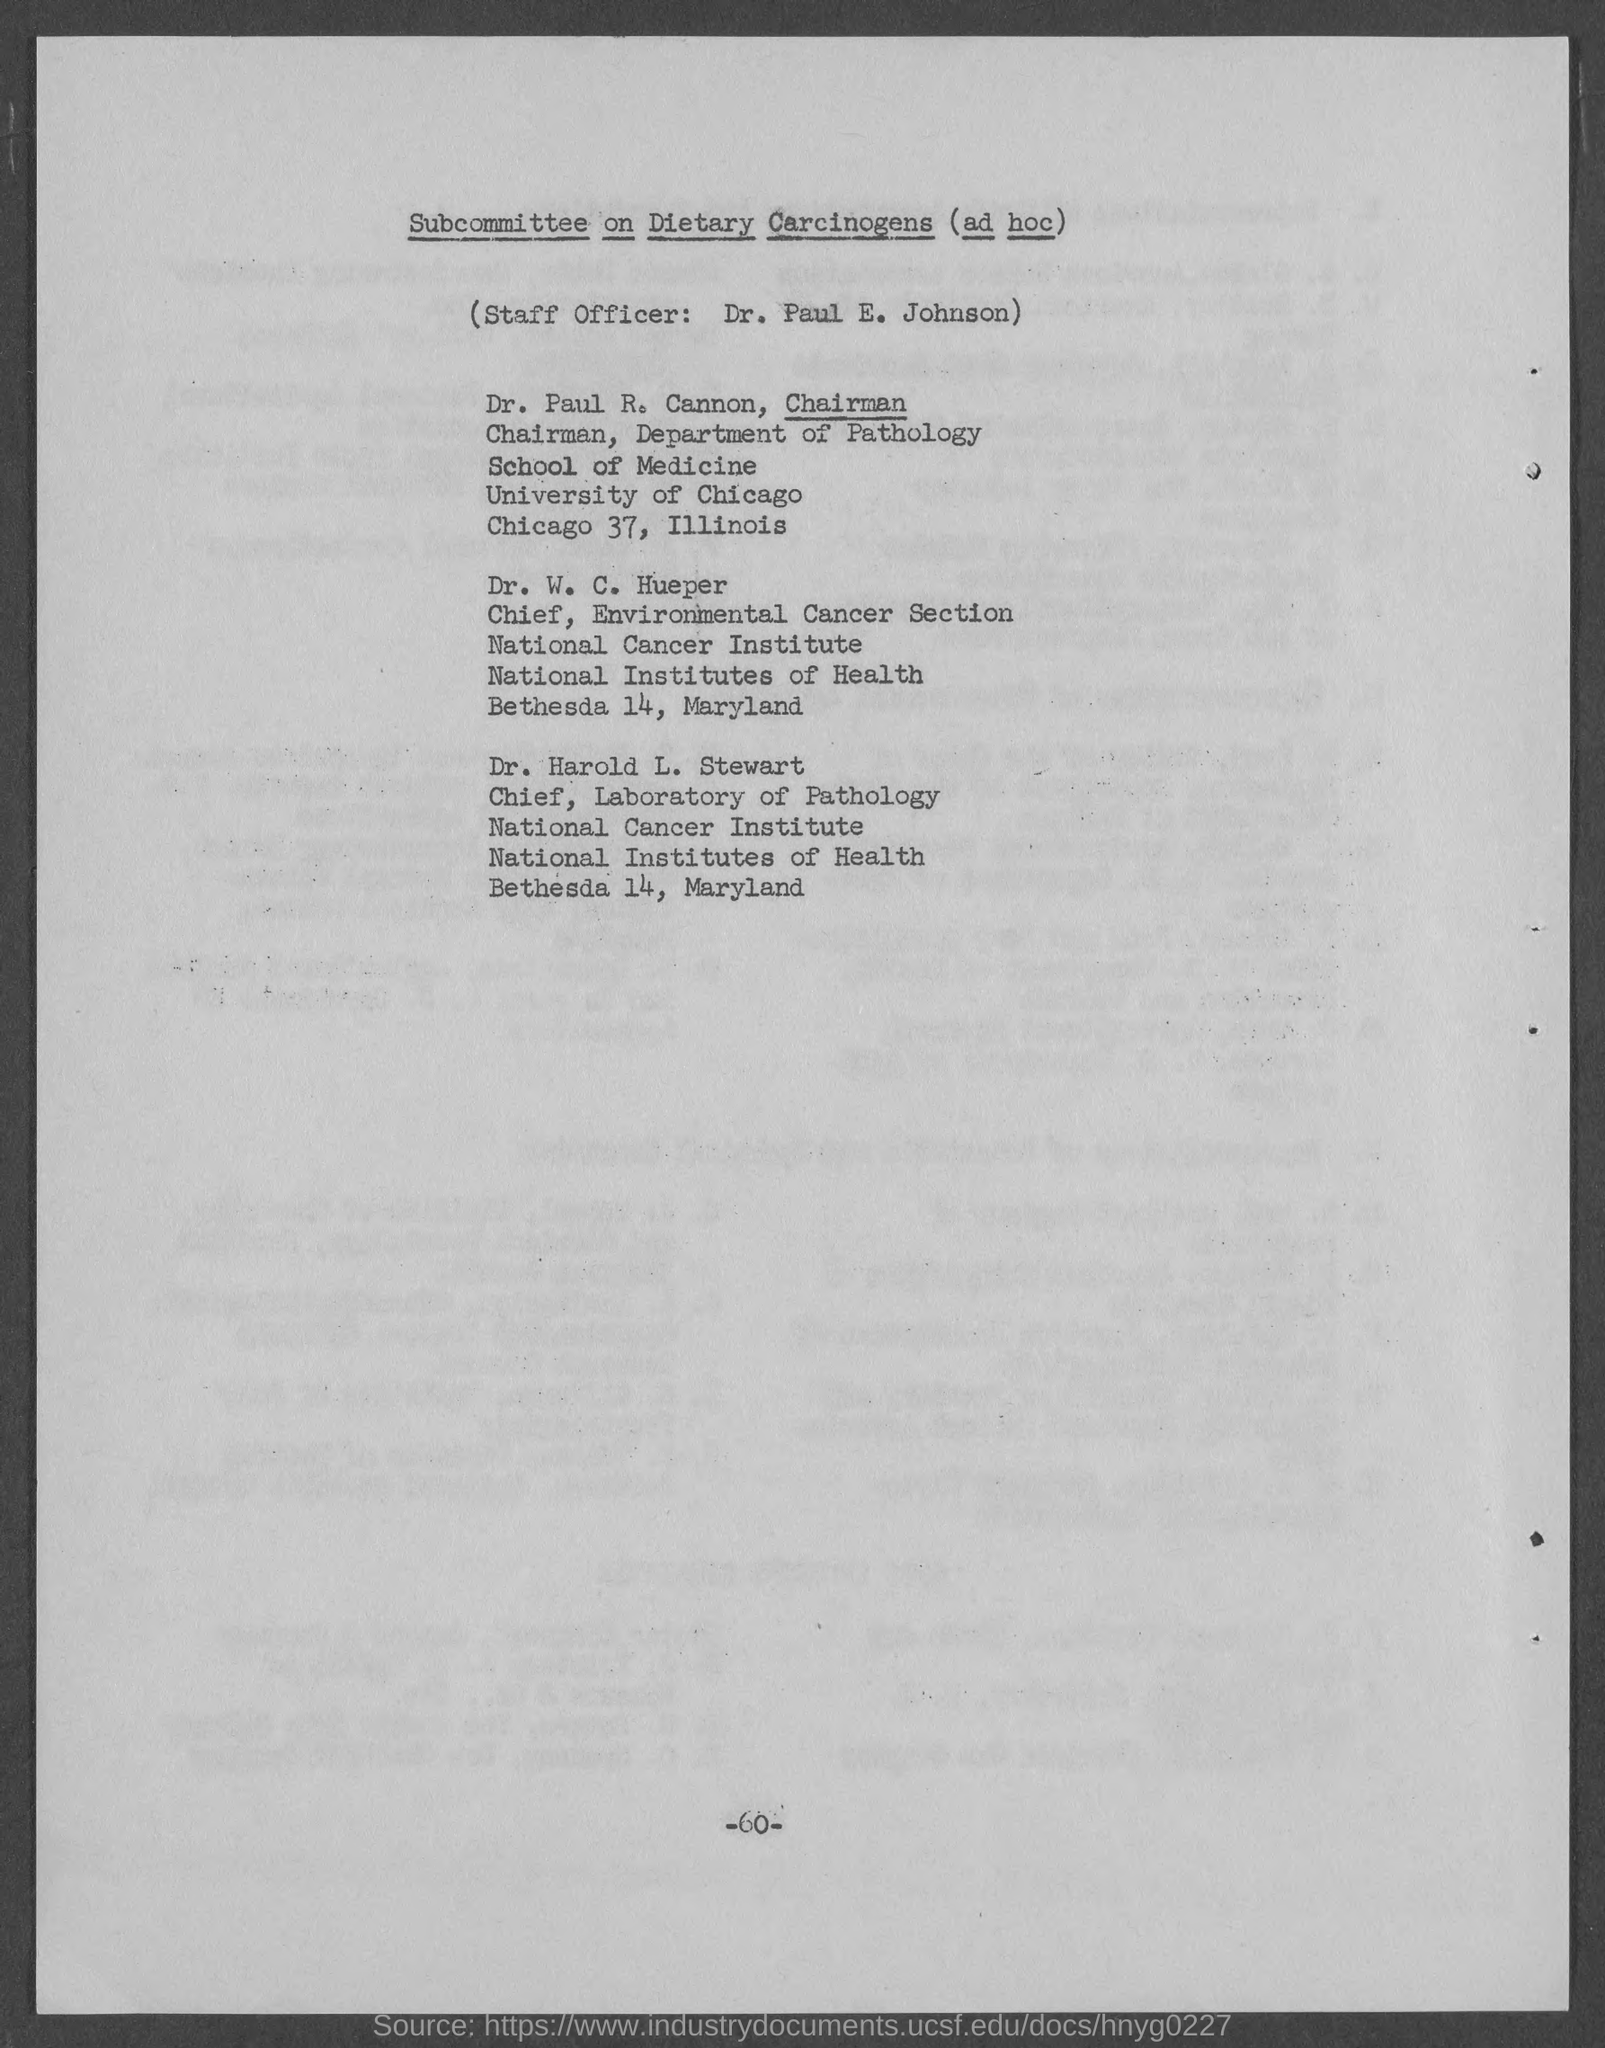Who is the Chief of Laboratory of Pathology, National Cancer Institute?
Give a very brief answer. Dr. Harold L. Stewart. 